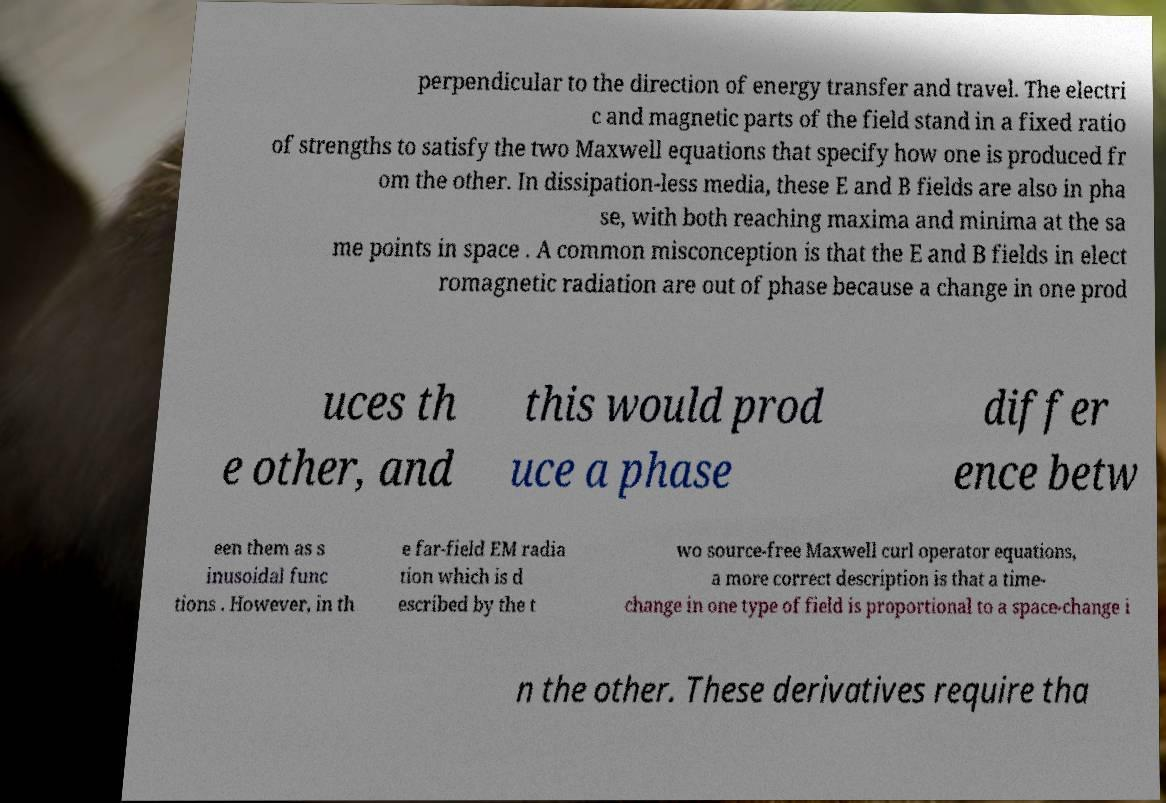I need the written content from this picture converted into text. Can you do that? perpendicular to the direction of energy transfer and travel. The electri c and magnetic parts of the field stand in a fixed ratio of strengths to satisfy the two Maxwell equations that specify how one is produced fr om the other. In dissipation-less media, these E and B fields are also in pha se, with both reaching maxima and minima at the sa me points in space . A common misconception is that the E and B fields in elect romagnetic radiation are out of phase because a change in one prod uces th e other, and this would prod uce a phase differ ence betw een them as s inusoidal func tions . However, in th e far-field EM radia tion which is d escribed by the t wo source-free Maxwell curl operator equations, a more correct description is that a time- change in one type of field is proportional to a space-change i n the other. These derivatives require tha 